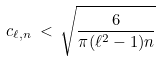<formula> <loc_0><loc_0><loc_500><loc_500>c _ { \ell , n } \, < \, \sqrt { \frac { 6 } { \pi ( \ell ^ { 2 } - 1 ) n } }</formula> 